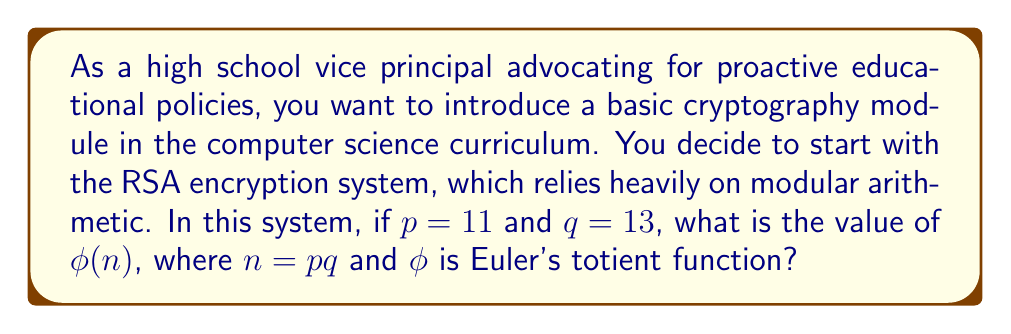What is the answer to this math problem? To solve this problem, we need to follow these steps:

1) First, let's recall the definition of Euler's totient function $\phi(n)$:
   For a prime number $p$, $\phi(p) = p - 1$

2) For a product of two distinct primes $p$ and $q$, $\phi(pq) = \phi(p) \cdot \phi(q)$

3) In our case, $p = 11$ and $q = 13$. So, we need to calculate:
   $$\phi(n) = \phi(11 \cdot 13) = \phi(11) \cdot \phi(13)$$

4) Now, let's calculate each part:
   $$\phi(11) = 11 - 1 = 10$$
   $$\phi(13) = 13 - 1 = 12$$

5) Therefore:
   $$\phi(n) = 10 \cdot 12 = 120$$

This value of $\phi(n)$ is crucial in the RSA encryption system as it's used to generate the public and private keys. Understanding this concept is fundamental to grasping how modern cryptography works, which is increasingly important in our digital age.
Answer: $\phi(n) = 120$ 